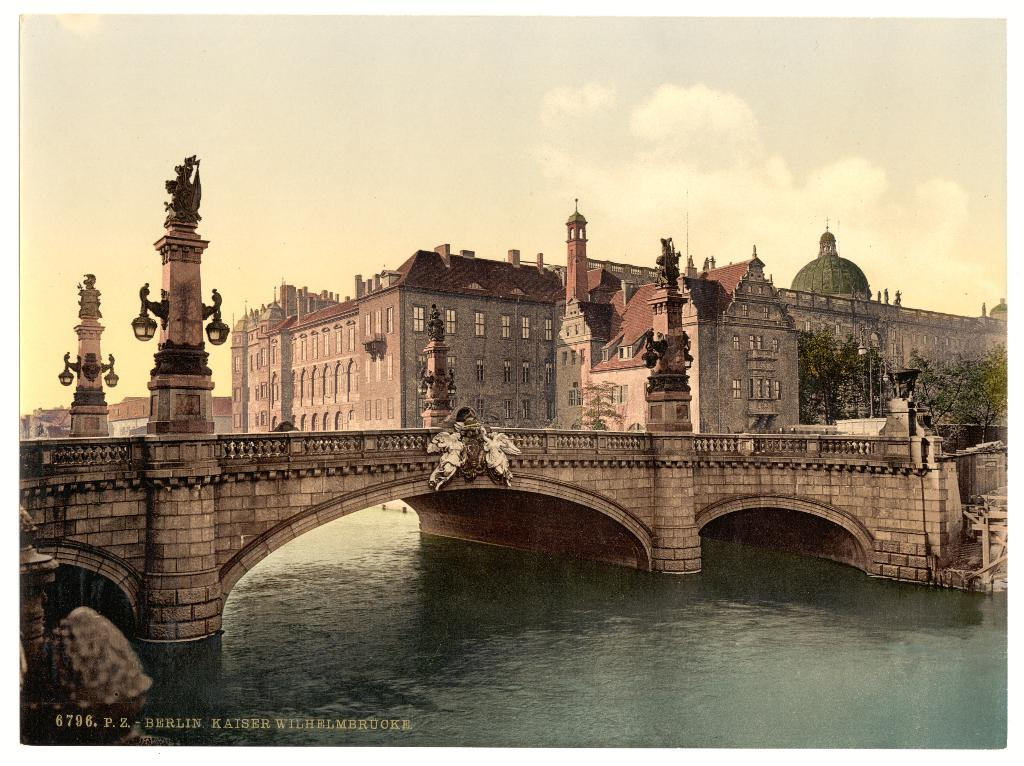What type of structure can be seen in the image? There is a bridge in the image. What is present beneath the bridge? There is water in the image. What type of artwork is visible in the image? There are sculptures in the image. What type of man-made structures can be seen in the image? There are buildings in the image. What type of illumination is present in the image? There are lights in the image. What type of natural vegetation is visible in the image? There are trees in the image. What part of the natural environment is visible in the image? The sky is visible in the image. Is there any additional marking on the image? Yes, there is a watermark on the image. What type of oil is being used to lift the bridge in the image? There is no oil or lifting mechanism present in the image; the bridge is stationary. What type of shame can be seen on the sculptures in the image? There is no shame present on the sculptures in the image; they are simply artistic creations. 